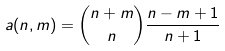Convert formula to latex. <formula><loc_0><loc_0><loc_500><loc_500>a ( n , m ) = \binom { n + m } { n } \frac { n - m + 1 } { n + 1 } \,</formula> 